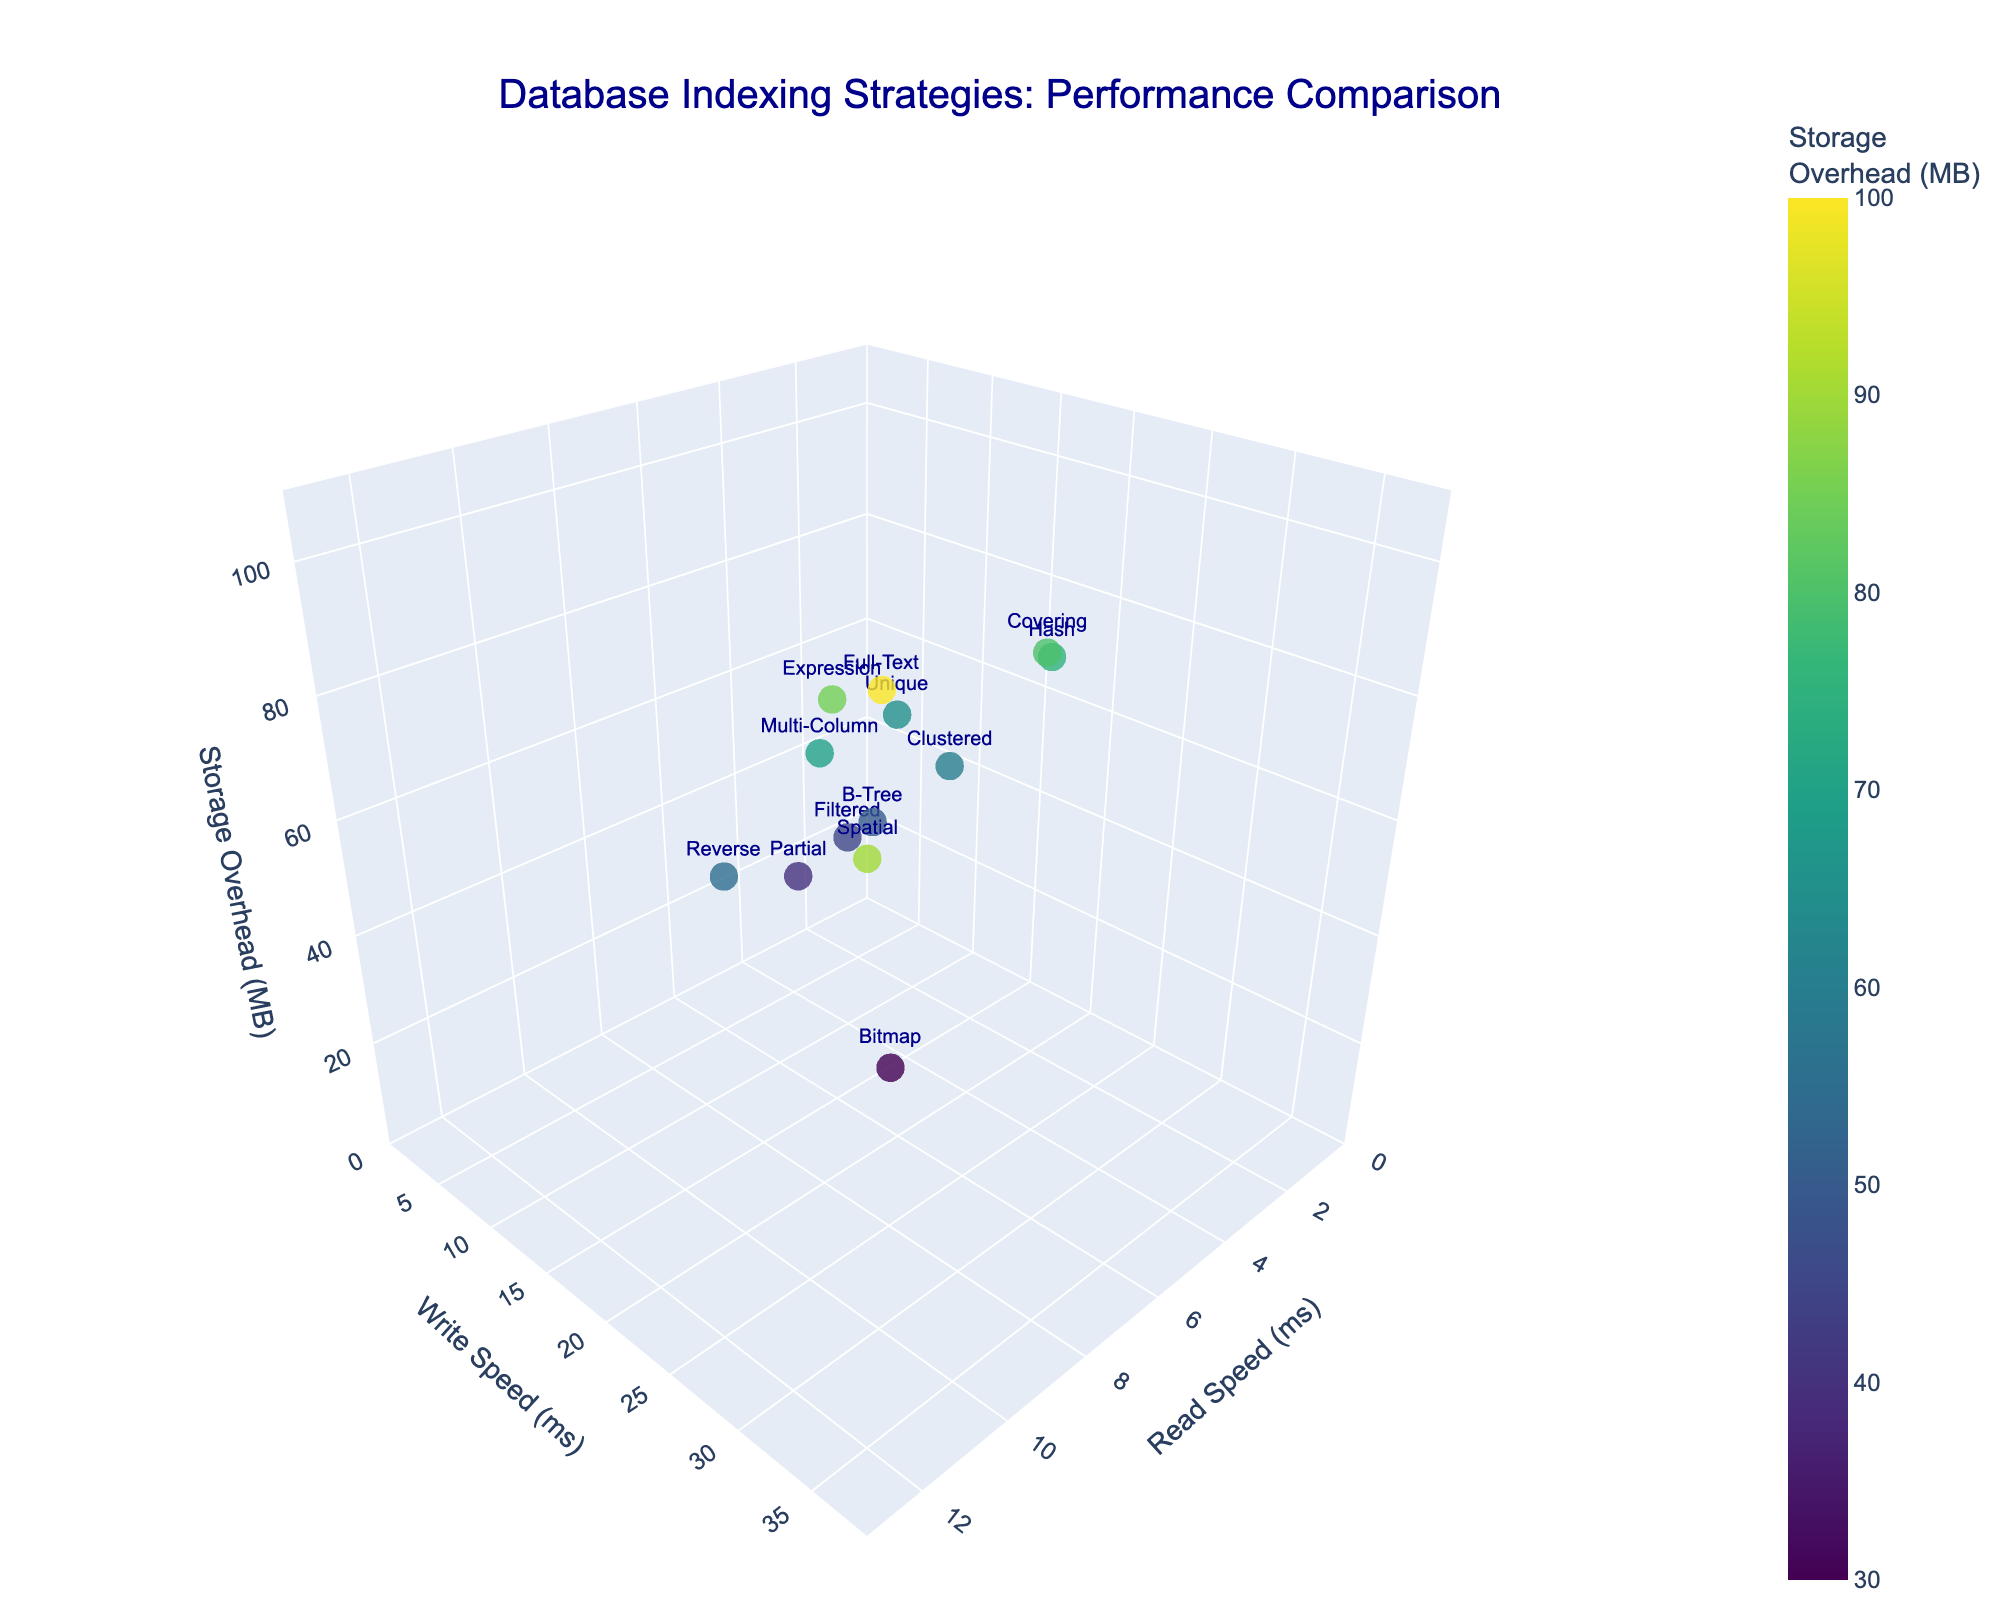How many different index types are displayed in the figure? Count the number of unique data points labeled distinctly on the plot.
Answer: 13 What are the axis labels in the figure? Look at the titles along the three axes of the 3D plot.
Answer: Read Speed (ms), Write Speed (ms), Storage Overhead (MB) Which index type has the highest read speed? Identify the data point with the highest value on the 'Read Speed (ms)' axis.
Answer: Spatial Which index type has the lowest storage overhead? Identify the data point with the smallest value on the 'Storage Overhead (MB)' axis.
Answer: Bitmap What is the read speed of the index type with the lowest write speed? Find the data point with the lowest value on the 'Write Speed (ms)' axis and then check its 'Read Speed (ms)'.
Answer: 6 ms (Partial) Which index type has a better read speed, B-Tree or Covering? Compare the 'Read Speed (ms)' values of B-Tree and Covering.
Answer: Covering What is the average write speed across all index types? Sum all 'Write Speed (ms)' values and divide by the number of index types (13).
Answer: 19.3 ms Among B-Tree, Hash, and Bitmap, which has the least storage overhead and what is it? Compare the 'Storage Overhead (MB)' values of B-Tree, Hash, and Bitmap. Bitmap has the smallest value.
Answer: 30 MB (Bitmap) Which two index types have the closest read speed values, and what are those values? Find two data points with the most similar 'Read Speed (ms)' values.
Answer: Filtered (5 ms) and B-Tree (5 ms) How does the storage overhead generally trend for higher write speeds among the index types? Observe the color gradient and the 'Storage Overhead (MB)' values relative to the 'Write Speed (ms)' values. A higher write speed often corresponds to higher storage overhead (more intense color).
Answer: Higher storage overhead 